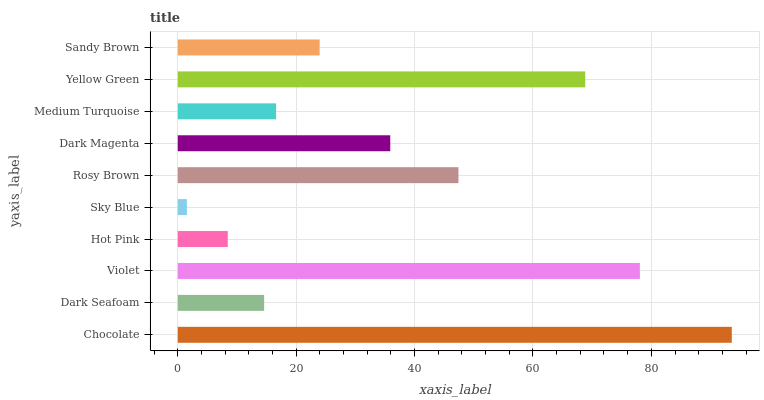Is Sky Blue the minimum?
Answer yes or no. Yes. Is Chocolate the maximum?
Answer yes or no. Yes. Is Dark Seafoam the minimum?
Answer yes or no. No. Is Dark Seafoam the maximum?
Answer yes or no. No. Is Chocolate greater than Dark Seafoam?
Answer yes or no. Yes. Is Dark Seafoam less than Chocolate?
Answer yes or no. Yes. Is Dark Seafoam greater than Chocolate?
Answer yes or no. No. Is Chocolate less than Dark Seafoam?
Answer yes or no. No. Is Dark Magenta the high median?
Answer yes or no. Yes. Is Sandy Brown the low median?
Answer yes or no. Yes. Is Chocolate the high median?
Answer yes or no. No. Is Yellow Green the low median?
Answer yes or no. No. 